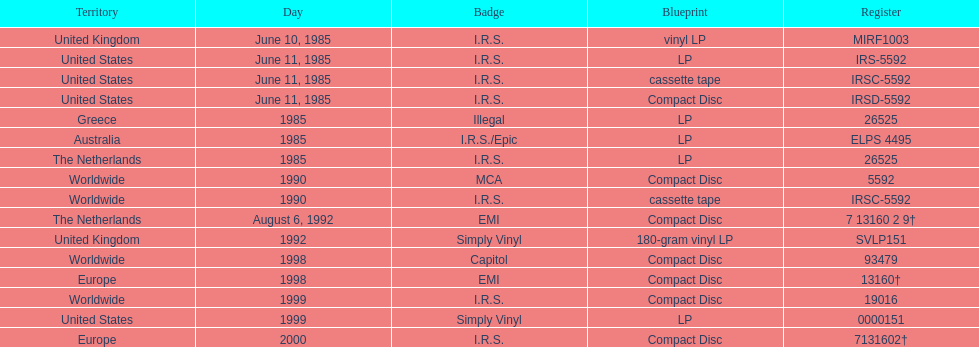How many times was the album released? 13. 